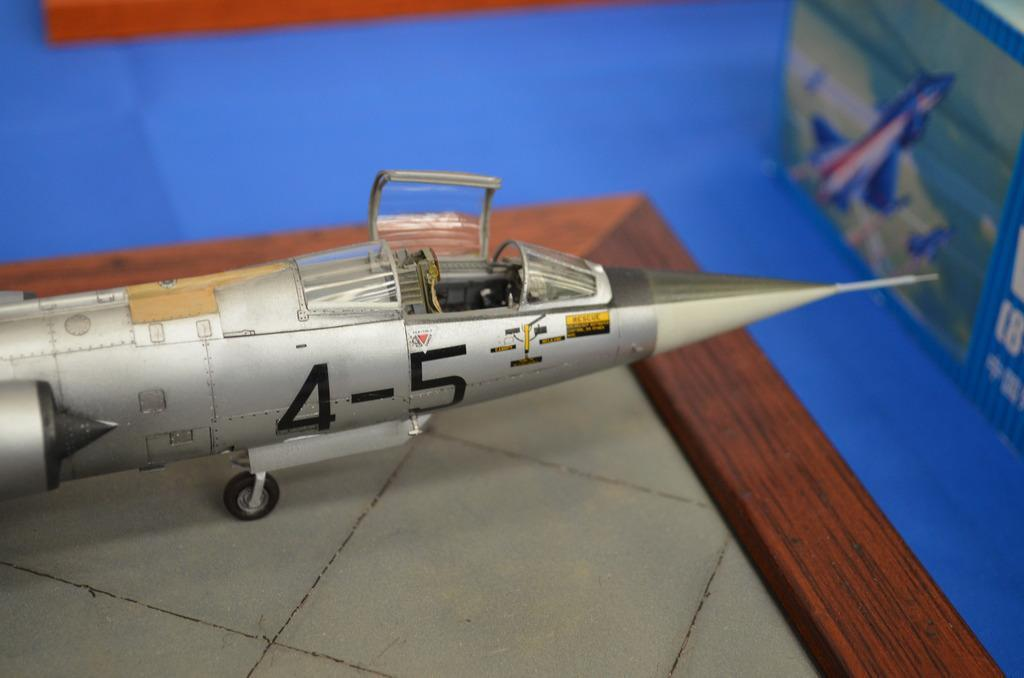What is the main subject of the image? The main subject of the image is a toy aircraft on a board. How many objects are on the blue surface? There are three objects on the blue surface. What is the blue object with text and images? The blue object with text and images appears to be a board. How does the toy aircraft interact with the mom in the image? There is no mom present in the image, so the toy aircraft does not interact with a mom. 